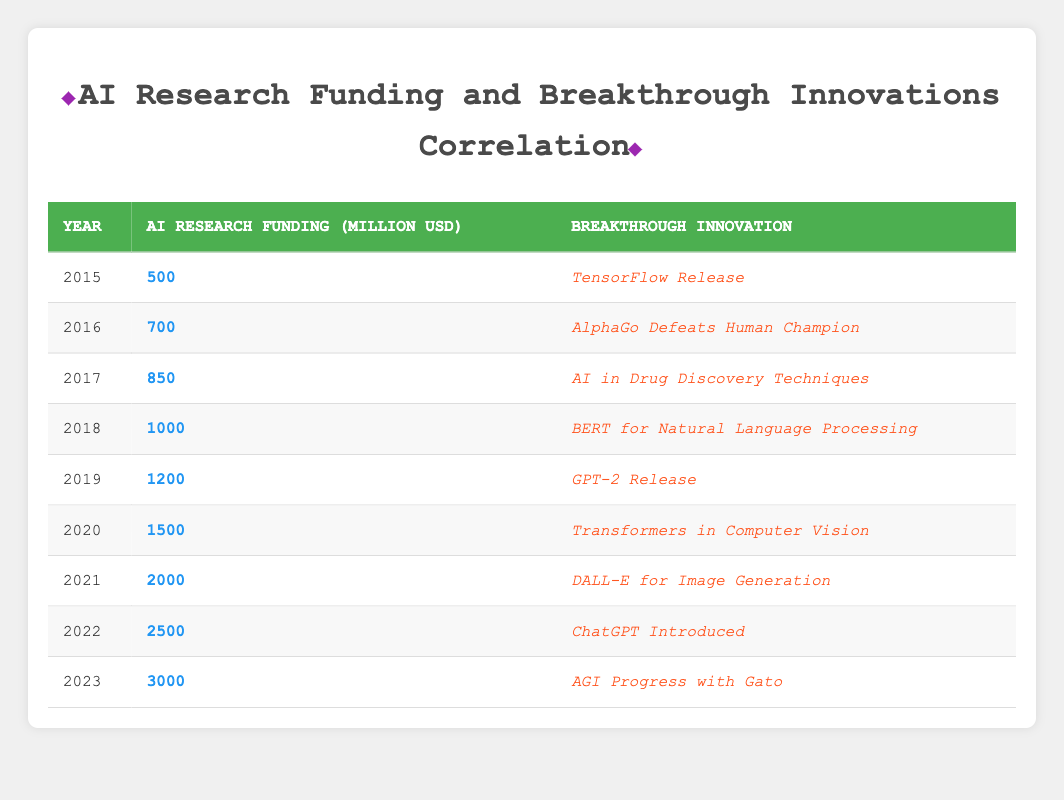What was the AI research funding in 2019? The table shows that in the year 2019, the AI research funding was listed as 1200 million USD.
Answer: 1200 million USD How many breakthrough innovations were introduced from 2015 to 2023? There are a total of 9 years listed from 2015 to 2023 and each year corresponds to one breakthrough innovation. Therefore, there were 9 innovations introduced during this time.
Answer: 9 What was the difference in AI research funding between 2020 and 2021? In 2020, the funding was 1500 million USD, and in 2021, it was 2000 million USD. The difference is calculated as 2000 - 1500 = 500 million USD.
Answer: 500 million USD Is it true that every year from 2015 to 2023 saw an increase in AI research funding? Yes, the funding amounts from 2015 to 2023 increase each year without any decreases in values.
Answer: Yes What was the total AI research funding from 2015 to 2023? The total funding is the sum of all the yearly funding: 500 + 700 + 850 + 1000 + 1200 + 1500 + 2000 + 2500 + 3000 = 9000 million USD.
Answer: 9000 million USD What breakthrough innovation was associated with the highest funding year? In 2023, the funding was at its highest level of 3000 million USD, and the associated breakthrough innovation was "AGI Progress with Gato."
Answer: AGI Progress with Gato How much did the funding grow from 2015 to 2022? The funding in 2015 was 500 million USD, and in 2022 it was 2500 million USD. The growth is 2500 - 500 = 2000 million USD.
Answer: 2000 million USD What was the AI research funding trend from 2015 to 2023? The trend shows a consistent increase in funding each year from 500 million USD in 2015 to 3000 million USD in 2023, indicating a positive upward trend in funding.
Answer: Positive upward trend Which year had the introduction of the innovation "ChatGPT"? According to the table, "ChatGPT Introduced" corresponds to the year 2022.
Answer: 2022 